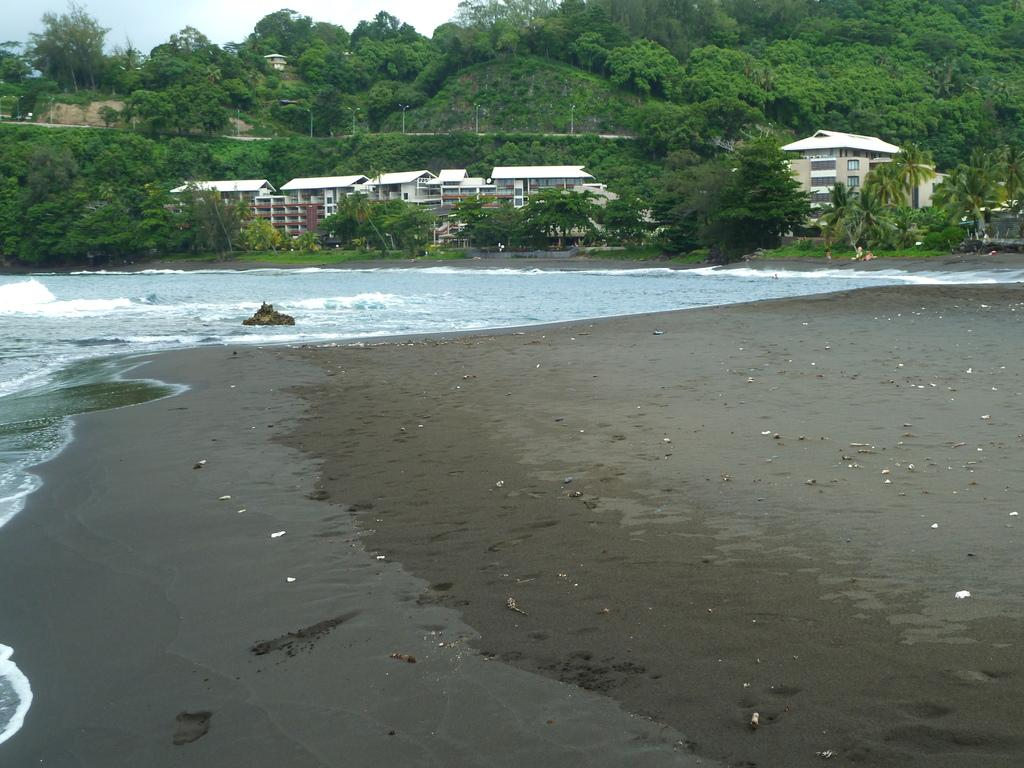What type of surface can be seen in the image? There is ground visible in the image. What is on the ground in the image? There are white-colored objects on the ground. What else is visible in the image besides the ground? There is water, trees, buildings, poles, and the sky visible in the image. Can you see a scarf being used as a wave in the image? There is no scarf or wave present in the image. 